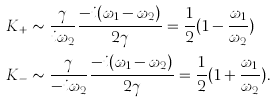<formula> <loc_0><loc_0><loc_500><loc_500>K _ { + } & \sim \frac { \gamma } { i \omega _ { 2 } } \frac { - i ( \omega _ { 1 } - \omega _ { 2 } ) } { 2 \gamma } = \frac { 1 } { 2 } ( 1 - \frac { \omega _ { 1 } } { \omega _ { 2 } } ) \\ K _ { - } & \sim \frac { \gamma } { - i \omega _ { 2 } } \frac { - i ( \omega _ { 1 } - \omega _ { 2 } ) } { 2 \gamma } = \frac { 1 } { 2 } ( 1 + \frac { \omega _ { 1 } } { \omega _ { 2 } } ) .</formula> 